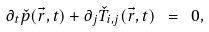<formula> <loc_0><loc_0><loc_500><loc_500>\partial _ { t } \check { p } ( \vec { r } , t ) + \partial _ { j } \check { T } _ { i , j } ( \vec { r } , t ) \ = \ 0 ,</formula> 